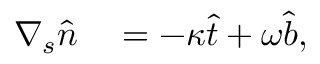Convert formula to latex. <formula><loc_0><loc_0><loc_500><loc_500>\begin{array} { r l } { \nabla _ { s } \widehat { n } } & = - \kappa \widehat { t } + \omega \widehat { b } , } \end{array}</formula> 